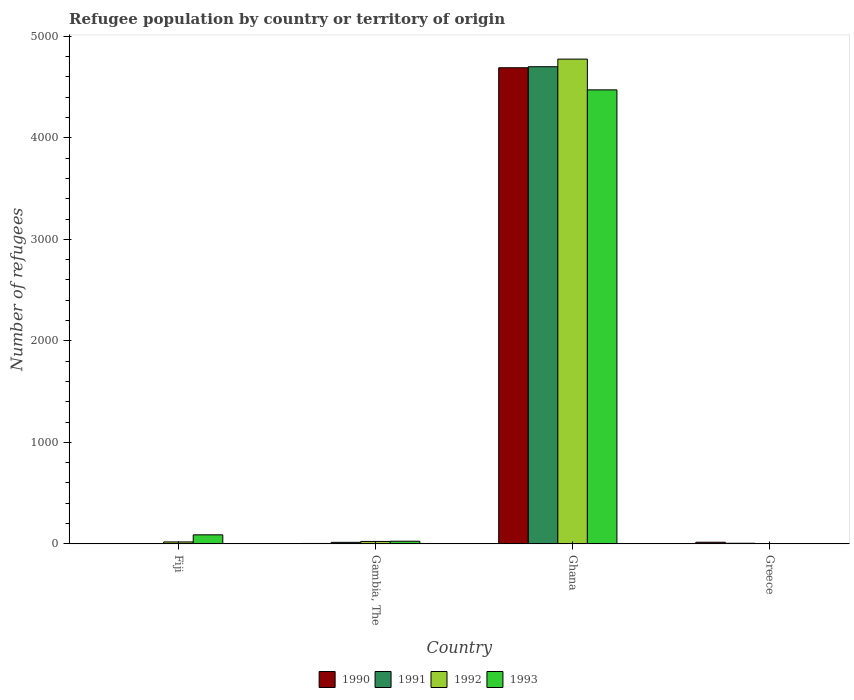How many different coloured bars are there?
Make the answer very short. 4. Are the number of bars per tick equal to the number of legend labels?
Offer a terse response. Yes. How many bars are there on the 3rd tick from the right?
Provide a short and direct response. 4. What is the label of the 1st group of bars from the left?
Provide a short and direct response. Fiji. In how many cases, is the number of bars for a given country not equal to the number of legend labels?
Make the answer very short. 0. Across all countries, what is the maximum number of refugees in 1992?
Provide a short and direct response. 4776. Across all countries, what is the minimum number of refugees in 1992?
Give a very brief answer. 1. In which country was the number of refugees in 1990 minimum?
Your answer should be compact. Fiji. What is the total number of refugees in 1993 in the graph?
Make the answer very short. 4589. What is the difference between the number of refugees in 1990 in Fiji and that in Ghana?
Offer a very short reply. -4690. What is the difference between the number of refugees in 1992 in Greece and the number of refugees in 1991 in Ghana?
Keep it short and to the point. -4700. What is the average number of refugees in 1990 per country?
Your answer should be very brief. 1178. What is the difference between the number of refugees of/in 1990 and number of refugees of/in 1993 in Fiji?
Your answer should be compact. -88. In how many countries, is the number of refugees in 1991 greater than 4400?
Your response must be concise. 1. What is the ratio of the number of refugees in 1992 in Ghana to that in Greece?
Provide a succinct answer. 4776. Is the difference between the number of refugees in 1990 in Gambia, The and Greece greater than the difference between the number of refugees in 1993 in Gambia, The and Greece?
Keep it short and to the point. No. What is the difference between the highest and the second highest number of refugees in 1991?
Ensure brevity in your answer.  4695. What is the difference between the highest and the lowest number of refugees in 1992?
Your answer should be very brief. 4775. Is it the case that in every country, the sum of the number of refugees in 1992 and number of refugees in 1990 is greater than the sum of number of refugees in 1991 and number of refugees in 1993?
Your response must be concise. No. How many bars are there?
Provide a succinct answer. 16. What is the difference between two consecutive major ticks on the Y-axis?
Your answer should be compact. 1000. Are the values on the major ticks of Y-axis written in scientific E-notation?
Your response must be concise. No. Does the graph contain any zero values?
Provide a short and direct response. No. Where does the legend appear in the graph?
Make the answer very short. Bottom center. How many legend labels are there?
Your response must be concise. 4. How are the legend labels stacked?
Keep it short and to the point. Horizontal. What is the title of the graph?
Ensure brevity in your answer.  Refugee population by country or territory of origin. What is the label or title of the X-axis?
Offer a very short reply. Country. What is the label or title of the Y-axis?
Keep it short and to the point. Number of refugees. What is the Number of refugees in 1990 in Fiji?
Give a very brief answer. 1. What is the Number of refugees in 1991 in Fiji?
Give a very brief answer. 1. What is the Number of refugees in 1992 in Fiji?
Make the answer very short. 19. What is the Number of refugees in 1993 in Fiji?
Provide a short and direct response. 89. What is the Number of refugees of 1990 in Gambia, The?
Ensure brevity in your answer.  4. What is the Number of refugees of 1991 in Gambia, The?
Your answer should be compact. 15. What is the Number of refugees in 1992 in Gambia, The?
Your response must be concise. 24. What is the Number of refugees of 1990 in Ghana?
Provide a succinct answer. 4691. What is the Number of refugees in 1991 in Ghana?
Provide a succinct answer. 4701. What is the Number of refugees in 1992 in Ghana?
Make the answer very short. 4776. What is the Number of refugees in 1993 in Ghana?
Offer a very short reply. 4473. What is the Number of refugees of 1990 in Greece?
Your answer should be compact. 16. What is the Number of refugees of 1992 in Greece?
Keep it short and to the point. 1. Across all countries, what is the maximum Number of refugees in 1990?
Ensure brevity in your answer.  4691. Across all countries, what is the maximum Number of refugees in 1991?
Your answer should be compact. 4701. Across all countries, what is the maximum Number of refugees of 1992?
Offer a very short reply. 4776. Across all countries, what is the maximum Number of refugees of 1993?
Your answer should be compact. 4473. Across all countries, what is the minimum Number of refugees in 1990?
Keep it short and to the point. 1. Across all countries, what is the minimum Number of refugees of 1991?
Offer a terse response. 1. What is the total Number of refugees of 1990 in the graph?
Provide a short and direct response. 4712. What is the total Number of refugees of 1991 in the graph?
Provide a short and direct response. 4723. What is the total Number of refugees in 1992 in the graph?
Ensure brevity in your answer.  4820. What is the total Number of refugees of 1993 in the graph?
Offer a very short reply. 4589. What is the difference between the Number of refugees in 1990 in Fiji and that in Gambia, The?
Your answer should be very brief. -3. What is the difference between the Number of refugees of 1992 in Fiji and that in Gambia, The?
Your answer should be very brief. -5. What is the difference between the Number of refugees in 1990 in Fiji and that in Ghana?
Offer a terse response. -4690. What is the difference between the Number of refugees of 1991 in Fiji and that in Ghana?
Give a very brief answer. -4700. What is the difference between the Number of refugees of 1992 in Fiji and that in Ghana?
Provide a succinct answer. -4757. What is the difference between the Number of refugees in 1993 in Fiji and that in Ghana?
Your response must be concise. -4384. What is the difference between the Number of refugees of 1990 in Fiji and that in Greece?
Your answer should be compact. -15. What is the difference between the Number of refugees in 1990 in Gambia, The and that in Ghana?
Offer a terse response. -4687. What is the difference between the Number of refugees in 1991 in Gambia, The and that in Ghana?
Provide a short and direct response. -4686. What is the difference between the Number of refugees of 1992 in Gambia, The and that in Ghana?
Your response must be concise. -4752. What is the difference between the Number of refugees in 1993 in Gambia, The and that in Ghana?
Give a very brief answer. -4447. What is the difference between the Number of refugees in 1991 in Gambia, The and that in Greece?
Ensure brevity in your answer.  9. What is the difference between the Number of refugees of 1992 in Gambia, The and that in Greece?
Ensure brevity in your answer.  23. What is the difference between the Number of refugees in 1990 in Ghana and that in Greece?
Offer a very short reply. 4675. What is the difference between the Number of refugees of 1991 in Ghana and that in Greece?
Your answer should be compact. 4695. What is the difference between the Number of refugees in 1992 in Ghana and that in Greece?
Ensure brevity in your answer.  4775. What is the difference between the Number of refugees of 1993 in Ghana and that in Greece?
Provide a succinct answer. 4472. What is the difference between the Number of refugees in 1990 in Fiji and the Number of refugees in 1991 in Gambia, The?
Your answer should be very brief. -14. What is the difference between the Number of refugees in 1991 in Fiji and the Number of refugees in 1992 in Gambia, The?
Offer a very short reply. -23. What is the difference between the Number of refugees in 1992 in Fiji and the Number of refugees in 1993 in Gambia, The?
Keep it short and to the point. -7. What is the difference between the Number of refugees in 1990 in Fiji and the Number of refugees in 1991 in Ghana?
Provide a short and direct response. -4700. What is the difference between the Number of refugees of 1990 in Fiji and the Number of refugees of 1992 in Ghana?
Make the answer very short. -4775. What is the difference between the Number of refugees in 1990 in Fiji and the Number of refugees in 1993 in Ghana?
Your answer should be very brief. -4472. What is the difference between the Number of refugees in 1991 in Fiji and the Number of refugees in 1992 in Ghana?
Your answer should be very brief. -4775. What is the difference between the Number of refugees of 1991 in Fiji and the Number of refugees of 1993 in Ghana?
Provide a short and direct response. -4472. What is the difference between the Number of refugees of 1992 in Fiji and the Number of refugees of 1993 in Ghana?
Provide a short and direct response. -4454. What is the difference between the Number of refugees of 1991 in Fiji and the Number of refugees of 1992 in Greece?
Provide a short and direct response. 0. What is the difference between the Number of refugees of 1991 in Fiji and the Number of refugees of 1993 in Greece?
Ensure brevity in your answer.  0. What is the difference between the Number of refugees of 1992 in Fiji and the Number of refugees of 1993 in Greece?
Your response must be concise. 18. What is the difference between the Number of refugees of 1990 in Gambia, The and the Number of refugees of 1991 in Ghana?
Offer a very short reply. -4697. What is the difference between the Number of refugees in 1990 in Gambia, The and the Number of refugees in 1992 in Ghana?
Your answer should be compact. -4772. What is the difference between the Number of refugees in 1990 in Gambia, The and the Number of refugees in 1993 in Ghana?
Give a very brief answer. -4469. What is the difference between the Number of refugees of 1991 in Gambia, The and the Number of refugees of 1992 in Ghana?
Your response must be concise. -4761. What is the difference between the Number of refugees in 1991 in Gambia, The and the Number of refugees in 1993 in Ghana?
Offer a very short reply. -4458. What is the difference between the Number of refugees in 1992 in Gambia, The and the Number of refugees in 1993 in Ghana?
Give a very brief answer. -4449. What is the difference between the Number of refugees in 1991 in Gambia, The and the Number of refugees in 1992 in Greece?
Provide a succinct answer. 14. What is the difference between the Number of refugees of 1992 in Gambia, The and the Number of refugees of 1993 in Greece?
Make the answer very short. 23. What is the difference between the Number of refugees of 1990 in Ghana and the Number of refugees of 1991 in Greece?
Provide a short and direct response. 4685. What is the difference between the Number of refugees of 1990 in Ghana and the Number of refugees of 1992 in Greece?
Provide a short and direct response. 4690. What is the difference between the Number of refugees in 1990 in Ghana and the Number of refugees in 1993 in Greece?
Make the answer very short. 4690. What is the difference between the Number of refugees of 1991 in Ghana and the Number of refugees of 1992 in Greece?
Your answer should be very brief. 4700. What is the difference between the Number of refugees of 1991 in Ghana and the Number of refugees of 1993 in Greece?
Ensure brevity in your answer.  4700. What is the difference between the Number of refugees in 1992 in Ghana and the Number of refugees in 1993 in Greece?
Provide a short and direct response. 4775. What is the average Number of refugees of 1990 per country?
Ensure brevity in your answer.  1178. What is the average Number of refugees in 1991 per country?
Make the answer very short. 1180.75. What is the average Number of refugees in 1992 per country?
Provide a short and direct response. 1205. What is the average Number of refugees of 1993 per country?
Your answer should be very brief. 1147.25. What is the difference between the Number of refugees in 1990 and Number of refugees in 1993 in Fiji?
Provide a short and direct response. -88. What is the difference between the Number of refugees of 1991 and Number of refugees of 1992 in Fiji?
Your answer should be compact. -18. What is the difference between the Number of refugees in 1991 and Number of refugees in 1993 in Fiji?
Offer a terse response. -88. What is the difference between the Number of refugees of 1992 and Number of refugees of 1993 in Fiji?
Your response must be concise. -70. What is the difference between the Number of refugees in 1990 and Number of refugees in 1991 in Gambia, The?
Ensure brevity in your answer.  -11. What is the difference between the Number of refugees in 1990 and Number of refugees in 1992 in Gambia, The?
Make the answer very short. -20. What is the difference between the Number of refugees of 1991 and Number of refugees of 1992 in Gambia, The?
Give a very brief answer. -9. What is the difference between the Number of refugees in 1992 and Number of refugees in 1993 in Gambia, The?
Your answer should be compact. -2. What is the difference between the Number of refugees of 1990 and Number of refugees of 1991 in Ghana?
Your answer should be compact. -10. What is the difference between the Number of refugees of 1990 and Number of refugees of 1992 in Ghana?
Your response must be concise. -85. What is the difference between the Number of refugees in 1990 and Number of refugees in 1993 in Ghana?
Offer a very short reply. 218. What is the difference between the Number of refugees of 1991 and Number of refugees of 1992 in Ghana?
Keep it short and to the point. -75. What is the difference between the Number of refugees of 1991 and Number of refugees of 1993 in Ghana?
Your answer should be very brief. 228. What is the difference between the Number of refugees in 1992 and Number of refugees in 1993 in Ghana?
Make the answer very short. 303. What is the difference between the Number of refugees in 1990 and Number of refugees in 1992 in Greece?
Make the answer very short. 15. What is the difference between the Number of refugees of 1991 and Number of refugees of 1992 in Greece?
Your answer should be compact. 5. What is the difference between the Number of refugees in 1991 and Number of refugees in 1993 in Greece?
Ensure brevity in your answer.  5. What is the ratio of the Number of refugees in 1990 in Fiji to that in Gambia, The?
Keep it short and to the point. 0.25. What is the ratio of the Number of refugees of 1991 in Fiji to that in Gambia, The?
Ensure brevity in your answer.  0.07. What is the ratio of the Number of refugees in 1992 in Fiji to that in Gambia, The?
Keep it short and to the point. 0.79. What is the ratio of the Number of refugees in 1993 in Fiji to that in Gambia, The?
Provide a succinct answer. 3.42. What is the ratio of the Number of refugees of 1992 in Fiji to that in Ghana?
Make the answer very short. 0. What is the ratio of the Number of refugees in 1993 in Fiji to that in Ghana?
Your answer should be compact. 0.02. What is the ratio of the Number of refugees of 1990 in Fiji to that in Greece?
Your response must be concise. 0.06. What is the ratio of the Number of refugees of 1992 in Fiji to that in Greece?
Your answer should be compact. 19. What is the ratio of the Number of refugees of 1993 in Fiji to that in Greece?
Provide a succinct answer. 89. What is the ratio of the Number of refugees in 1990 in Gambia, The to that in Ghana?
Provide a short and direct response. 0. What is the ratio of the Number of refugees of 1991 in Gambia, The to that in Ghana?
Provide a succinct answer. 0. What is the ratio of the Number of refugees in 1992 in Gambia, The to that in Ghana?
Provide a succinct answer. 0.01. What is the ratio of the Number of refugees of 1993 in Gambia, The to that in Ghana?
Ensure brevity in your answer.  0.01. What is the ratio of the Number of refugees in 1993 in Gambia, The to that in Greece?
Keep it short and to the point. 26. What is the ratio of the Number of refugees of 1990 in Ghana to that in Greece?
Your answer should be compact. 293.19. What is the ratio of the Number of refugees of 1991 in Ghana to that in Greece?
Offer a terse response. 783.5. What is the ratio of the Number of refugees of 1992 in Ghana to that in Greece?
Provide a short and direct response. 4776. What is the ratio of the Number of refugees of 1993 in Ghana to that in Greece?
Your response must be concise. 4473. What is the difference between the highest and the second highest Number of refugees of 1990?
Your response must be concise. 4675. What is the difference between the highest and the second highest Number of refugees of 1991?
Offer a terse response. 4686. What is the difference between the highest and the second highest Number of refugees in 1992?
Ensure brevity in your answer.  4752. What is the difference between the highest and the second highest Number of refugees in 1993?
Your response must be concise. 4384. What is the difference between the highest and the lowest Number of refugees in 1990?
Ensure brevity in your answer.  4690. What is the difference between the highest and the lowest Number of refugees of 1991?
Your answer should be compact. 4700. What is the difference between the highest and the lowest Number of refugees in 1992?
Your answer should be very brief. 4775. What is the difference between the highest and the lowest Number of refugees of 1993?
Your answer should be compact. 4472. 